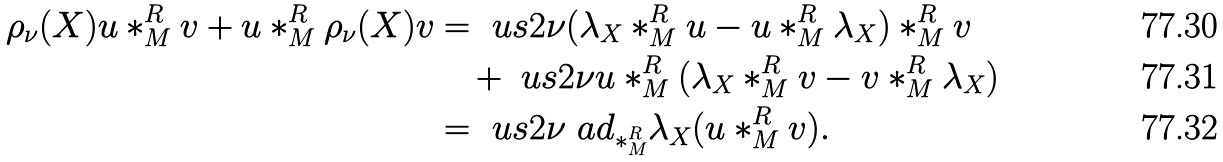<formula> <loc_0><loc_0><loc_500><loc_500>\rho _ { \nu } ( X ) u \ast _ { M } ^ { R } v + u \ast _ { M } ^ { R } \rho _ { \nu } ( X ) v & = \ u s { 2 \nu } ( \lambda _ { X } \ast _ { M } ^ { R } u - u \ast _ { M } ^ { R } \lambda _ { X } ) \ast _ { M } ^ { R } v \\ & \quad + \ u s { 2 \nu } u \ast _ { M } ^ { R } ( \lambda _ { X } \ast _ { M } ^ { R } v - v \ast _ { M } ^ { R } \lambda _ { X } ) \\ & = \ u s { 2 \nu } \ a d _ { \ast _ { M } ^ { R } } \lambda _ { X } ( u \ast _ { M } ^ { R } v ) .</formula> 